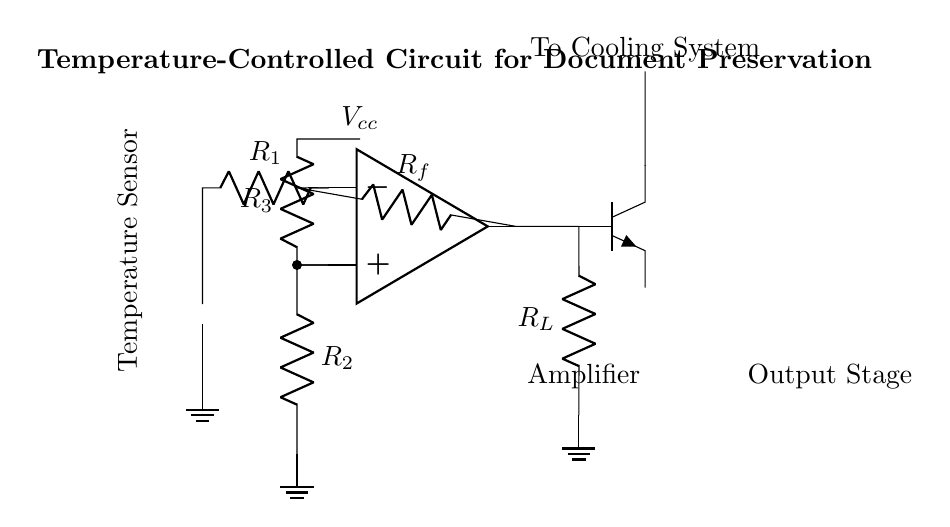What type of temperature sensor is used in this circuit? The circuit diagram indicates the use of a thermistor, which is a type of temperature sensor that changes resistance with temperature.
Answer: thermistor What is the purpose of the R_f resistor in this circuit? The R_f resistor is used in the feedback path of the operational amplifier to determine the gain of the circuit, affecting how the output signal is amplified based on the input from the thermistor.
Answer: gain adjustment Where does the output of the amplifier go? The output from the operational amplifier is connected to a transistor, which then drives a load (denoted as R_L) and eventually leads to the cooling system for document preservation.
Answer: cooling system How many resistors are there in total in this circuit? There are a total of four resistors in the circuit: R_1, R_2, R_3, and R_f.
Answer: four What is the role of the R_L resistor? The R_L resistor serves as a load resistor in the output stage of the circuit, managing the current flow to the cooling system and assisting in the effective dissipation of heat.
Answer: load management What is the function of the operational amplifier in this circuit? The operational amplifier amplifies the voltage difference between its input terminals, which allows for precise control of the cooling system based on the temperature readings from the thermistor.
Answer: signal amplification What is the main purpose of this circuit? The primary purpose of this circuit is to maintain a controlled temperature environment for the preservation of delicate genealogical documents by activating a cooling system as needed.
Answer: temperature control 